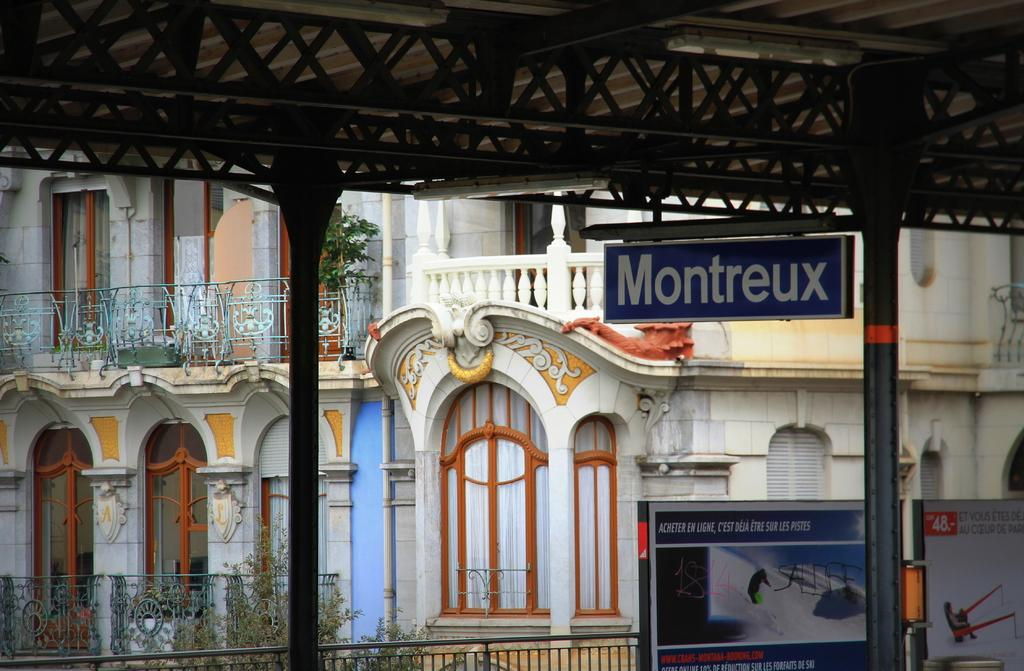What is located in the middle of the image? There are sign boards and a pole in the middle of the image. What can be found on the sign boards? There is text on the sign boards in the middle of the image. What can be seen in the background of the image? There are buildings, plants, a railing, a pole, windows, and a roof in the background of the image. What type of machine can be seen in the image? There is no machine present in the image. How many geese are involved in the discussion in the image? There is no discussion or geese present in the image. 